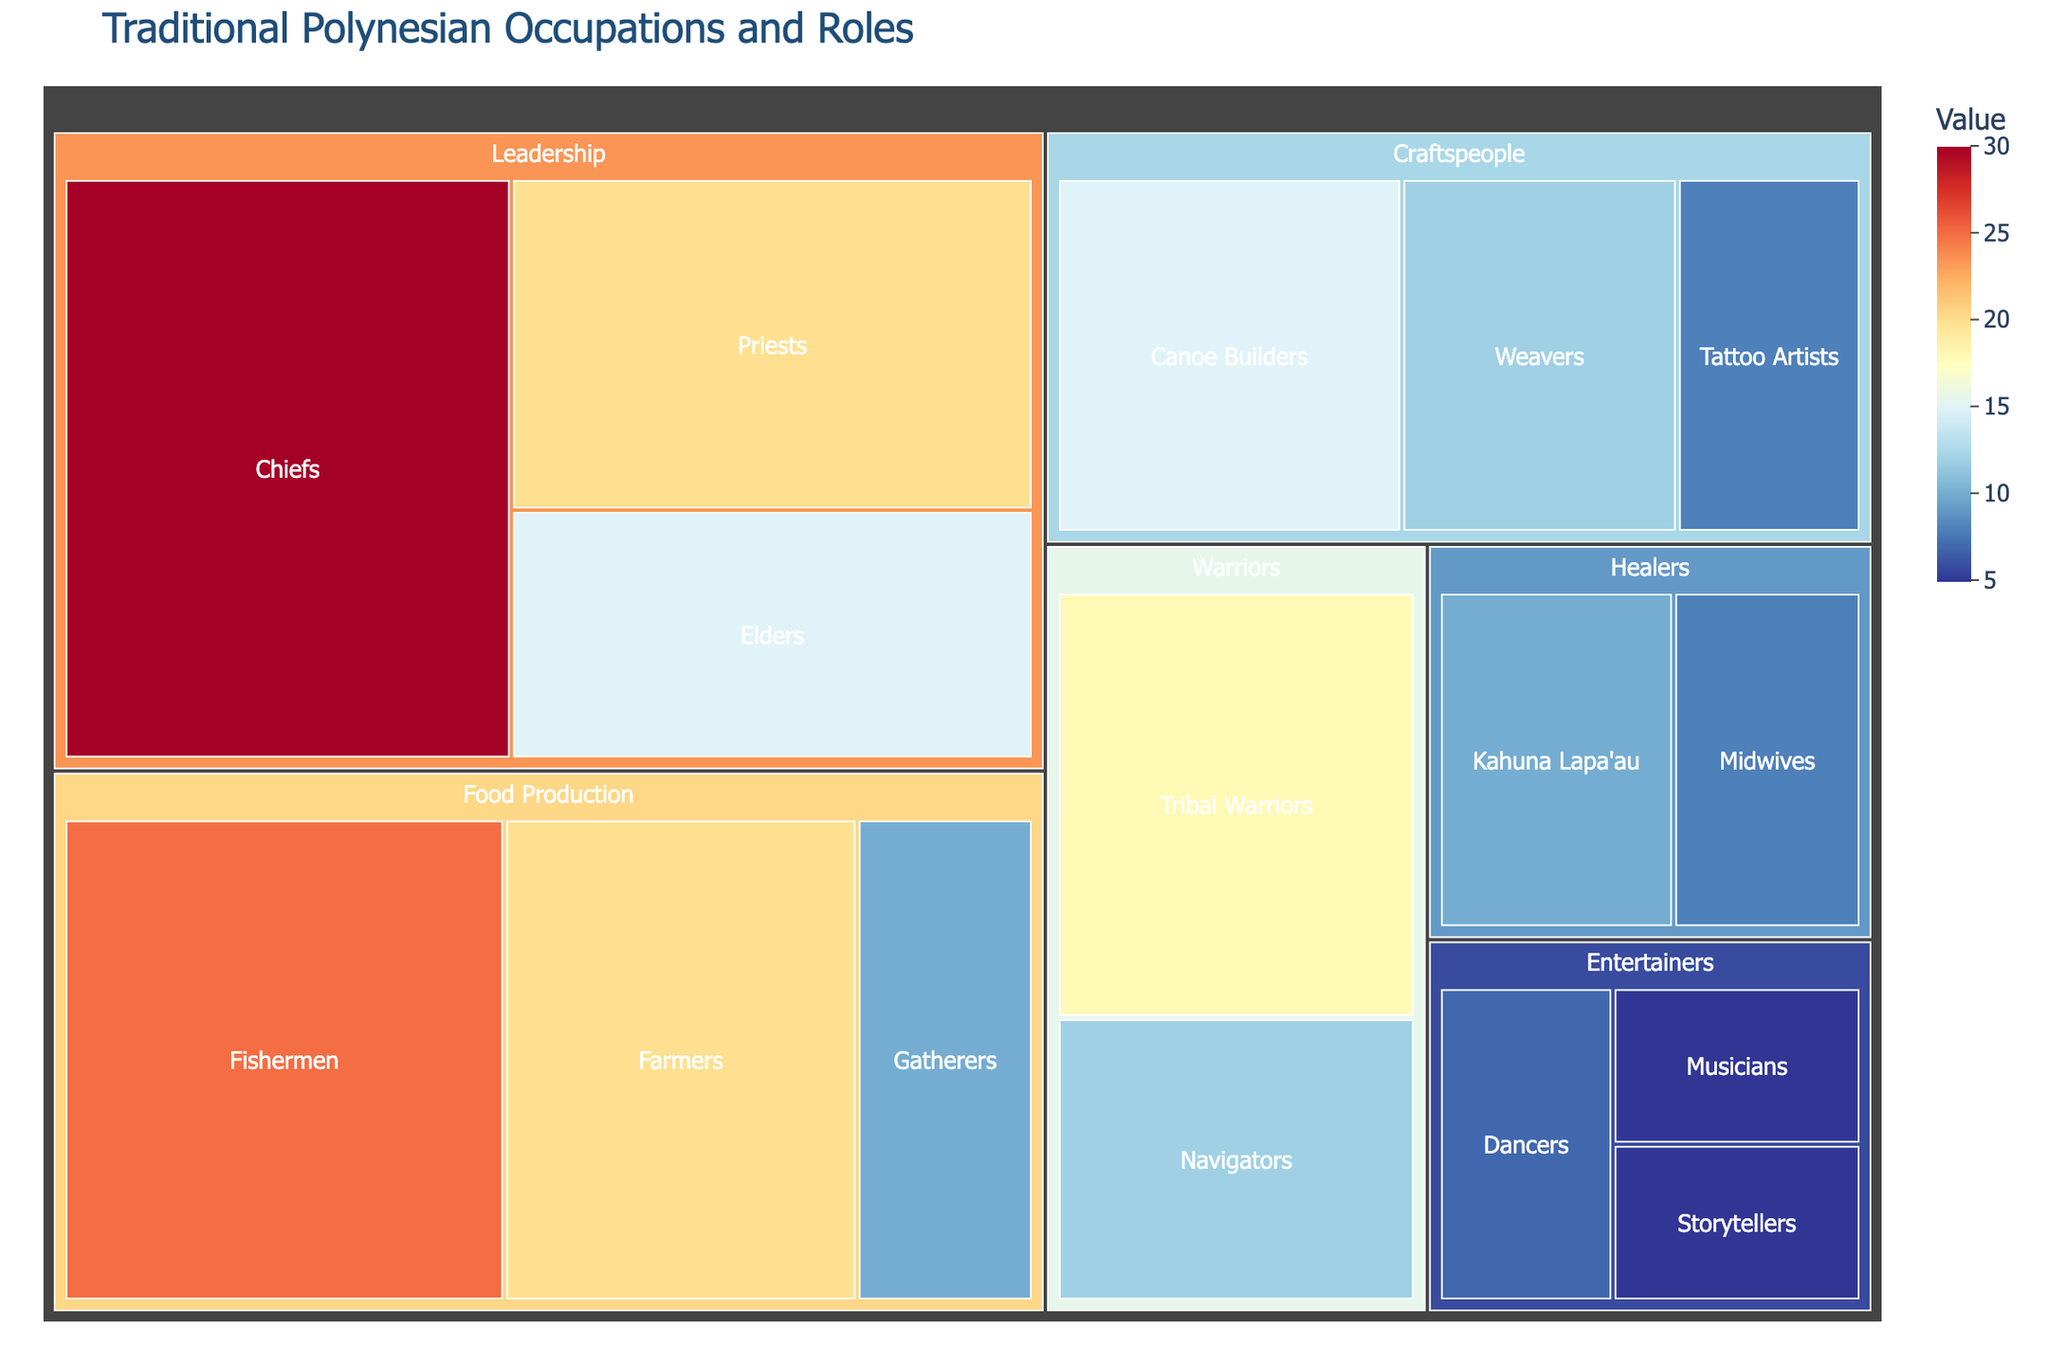Which category holds the highest value? The category with the highest value has the greatest sum of the subcategory values. Summing up the 'Leadership' category: Chiefs(30) + Priests(20) + Elders(15) = 65. Food Production: Fishermen(25) + Farmers(20) + Gatherers(10) = 55. Craftspeople: Canoe Builders(15) + Weavers(12) + Tattoo Artists(8) = 35. Healers: Kahuna Lapa'au(10) + Midwives(8) = 18. Warriors: Tribal Warriors(18) + Navigators(12) = 30. Entertainers: Dancers(7) + Musicians(5) + Storytellers(5) = 17. The highest value category is 'Leadership' with 65.
Answer: Leadership What is the total value of all the categories combined? Sum all values in each subcategory: Chiefs(30) + Priests(20) + Elders(15) + Fishermen(25) + Farmers(20) + Gatherers(10) + Canoe Builders(15) + Weavers(12) + Tattoo Artists(8) + Kahuna Lapa'au(10) + Midwives(8) + Tribal Warriors(18) + Navigators(12) + Dancers(7) + Musicians(5) + Storytellers(5), which equals 220.
Answer: 220 What is the combined value of the 'Healers' and 'Entertainers' categories? Add the values of the subcategories for 'Healers' and 'Entertainers'. Healers: Kahuna Lapa'au(10) + Midwives(8) = 18. Entertainers: Dancers(7) + Musicians(5) + Storytellers(5) = 17. Combined value is 18 + 17 = 35.
Answer: 35 Which category has a larger total value: 'Warriors' or 'Craftspeople'? Sum the values in the 'Warriors' and 'Craftspeople' categories. Warriors: Tribal Warriors(18) + Navigators(12) = 30. Craftspeople: Canoe Builders(15) + Weavers(12) + Tattoo Artists(8) = 35. Craftspeople has a larger value.
Answer: Craftspeople What is the average value of the 'Food Production' subcategories? Add the values of the subcategories and divide by the number of subcategories. Food Production: Fishermen(25) + Farmers(20) + Gatherers(10) = 55. There are 3 subcategories, so 55 / 3 = 18.33 (approx).
Answer: 18.33 Which subcategory in 'Leadership' has the highest value and what is it? Look at the values of the 'Leadership' subcategories: Chiefs(30), Priests(20), Elders(15). The highest value is 'Chiefs' with 30.
Answer: Chiefs, 30 By how much does the value of 'Fishermen' in 'Food Production' exceed the value of 'Tribal Warriors' in 'Warriors'? Find the values of 'Fishermen' and 'Tribal Warriors'. Fishermen(25), Tribal Warriors(18). The difference is 25 - 18 = 7.
Answer: 7 